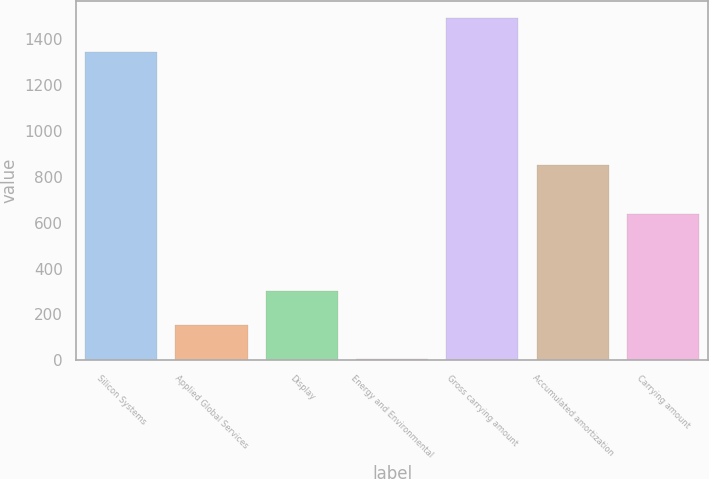Convert chart to OTSL. <chart><loc_0><loc_0><loc_500><loc_500><bar_chart><fcel>Silicon Systems<fcel>Applied Global Services<fcel>Display<fcel>Energy and Environmental<fcel>Gross carrying amount<fcel>Accumulated amortization<fcel>Carrying amount<nl><fcel>1346<fcel>153.4<fcel>301.8<fcel>5<fcel>1494.4<fcel>853<fcel>636<nl></chart> 